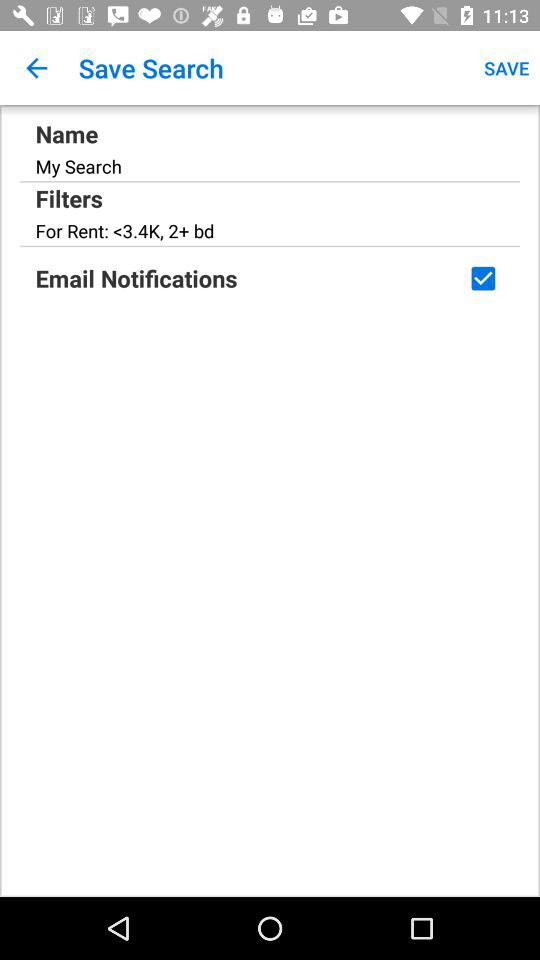Is "Email Notifications" enabled or disabled? "Email Notifications" is enabled. 